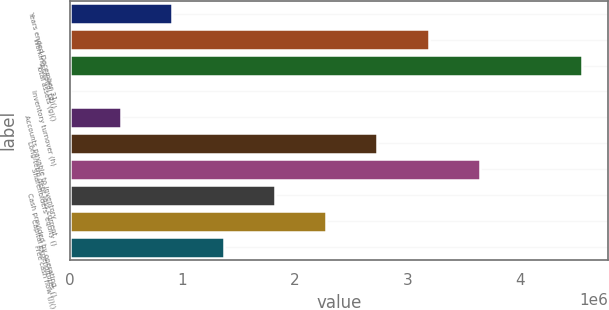Convert chart. <chart><loc_0><loc_0><loc_500><loc_500><bar_chart><fcel>Years ended December 31<fcel>Working capital (g)()<fcel>Total assets (g)()<fcel>Inventory turnover (h)<fcel>Accounts payable to inventory<fcel>Long-term debt less current<fcel>Shareholders' equity ()<fcel>Cash provided by operating<fcel>Capital expenditures ()<fcel>Free cash flow (j)()<nl><fcel>910318<fcel>3.18611e+06<fcel>4.55159e+06<fcel>1.6<fcel>455160<fcel>2.73095e+06<fcel>3.64127e+06<fcel>1.82064e+06<fcel>2.27579e+06<fcel>1.36548e+06<nl></chart> 